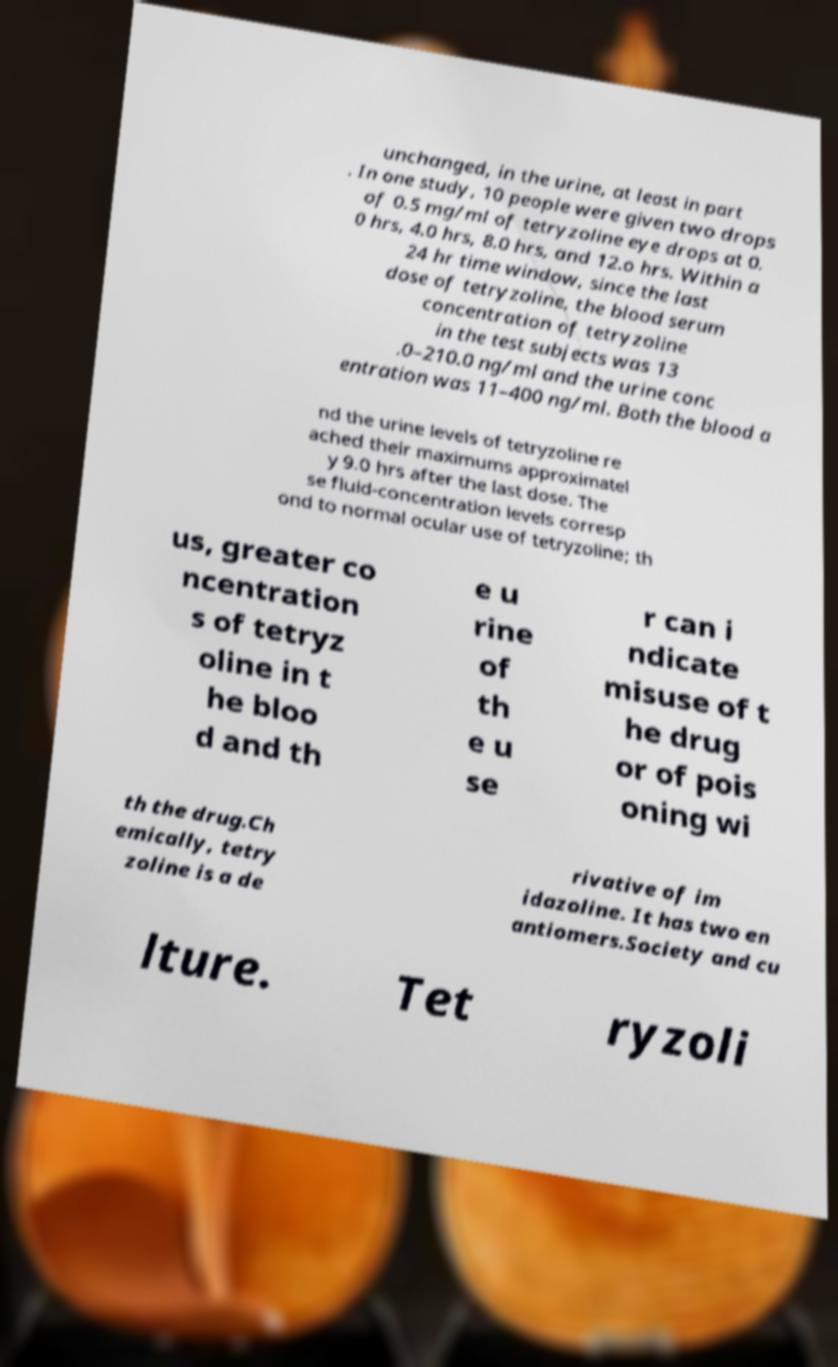Please read and relay the text visible in this image. What does it say? unchanged, in the urine, at least in part . In one study, 10 people were given two drops of 0.5 mg/ml of tetryzoline eye drops at 0. 0 hrs, 4.0 hrs, 8.0 hrs, and 12.o hrs. Within a 24 hr time window, since the last dose of tetryzoline, the blood serum concentration of tetryzoline in the test subjects was 13 .0–210.0 ng/ml and the urine conc entration was 11–400 ng/ml. Both the blood a nd the urine levels of tetryzoline re ached their maximums approximatel y 9.0 hrs after the last dose. The se fluid-concentration levels corresp ond to normal ocular use of tetryzoline; th us, greater co ncentration s of tetryz oline in t he bloo d and th e u rine of th e u se r can i ndicate misuse of t he drug or of pois oning wi th the drug.Ch emically, tetry zoline is a de rivative of im idazoline. It has two en antiomers.Society and cu lture. Tet ryzoli 